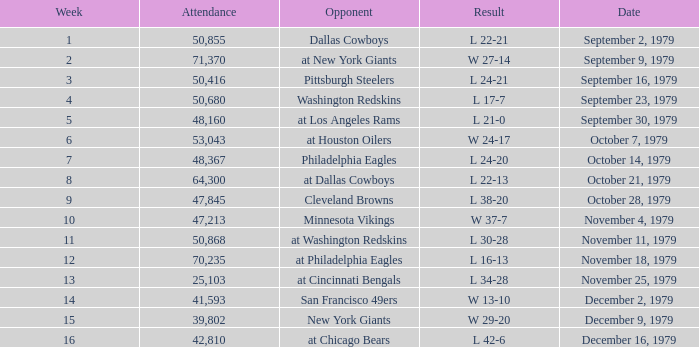I'm looking to parse the entire table for insights. Could you assist me with that? {'header': ['Week', 'Attendance', 'Opponent', 'Result', 'Date'], 'rows': [['1', '50,855', 'Dallas Cowboys', 'L 22-21', 'September 2, 1979'], ['2', '71,370', 'at New York Giants', 'W 27-14', 'September 9, 1979'], ['3', '50,416', 'Pittsburgh Steelers', 'L 24-21', 'September 16, 1979'], ['4', '50,680', 'Washington Redskins', 'L 17-7', 'September 23, 1979'], ['5', '48,160', 'at Los Angeles Rams', 'L 21-0', 'September 30, 1979'], ['6', '53,043', 'at Houston Oilers', 'W 24-17', 'October 7, 1979'], ['7', '48,367', 'Philadelphia Eagles', 'L 24-20', 'October 14, 1979'], ['8', '64,300', 'at Dallas Cowboys', 'L 22-13', 'October 21, 1979'], ['9', '47,845', 'Cleveland Browns', 'L 38-20', 'October 28, 1979'], ['10', '47,213', 'Minnesota Vikings', 'W 37-7', 'November 4, 1979'], ['11', '50,868', 'at Washington Redskins', 'L 30-28', 'November 11, 1979'], ['12', '70,235', 'at Philadelphia Eagles', 'L 16-13', 'November 18, 1979'], ['13', '25,103', 'at Cincinnati Bengals', 'L 34-28', 'November 25, 1979'], ['14', '41,593', 'San Francisco 49ers', 'W 13-10', 'December 2, 1979'], ['15', '39,802', 'New York Giants', 'W 29-20', 'December 9, 1979'], ['16', '42,810', 'at Chicago Bears', 'L 42-6', 'December 16, 1979']]} What is the highest week when attendance is greater than 64,300 with a result of w 27-14? 2.0. 